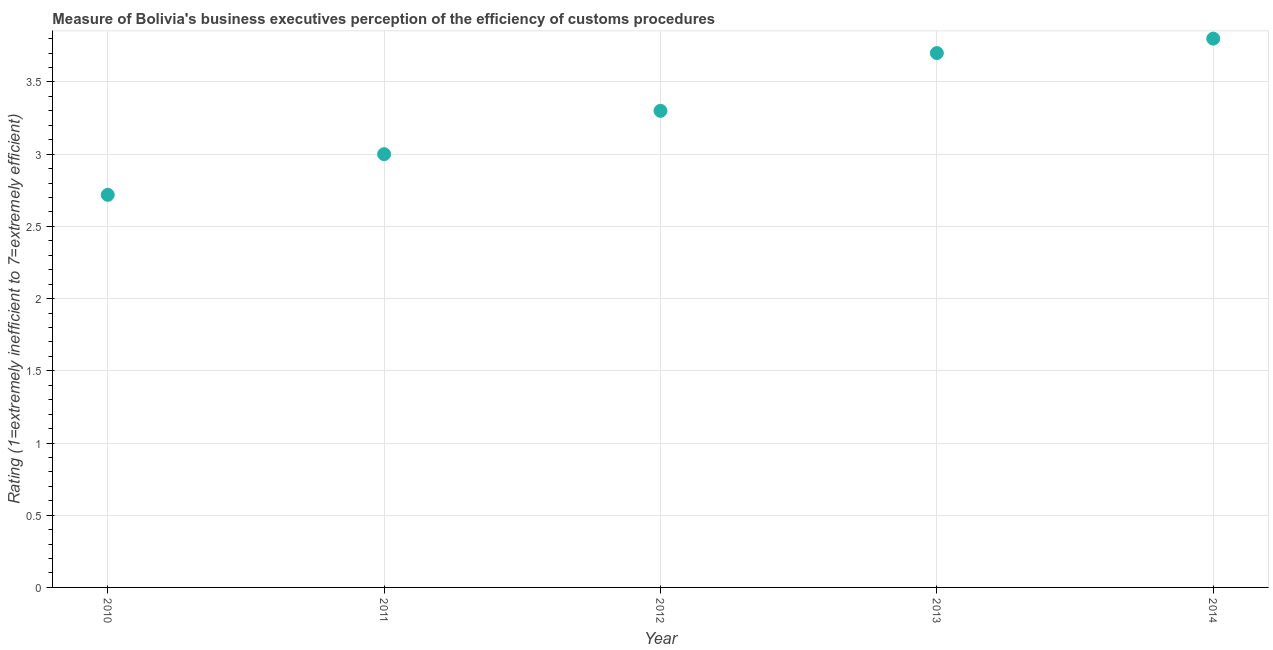Across all years, what is the minimum rating measuring burden of customs procedure?
Give a very brief answer. 2.72. What is the sum of the rating measuring burden of customs procedure?
Your answer should be very brief. 16.52. What is the difference between the rating measuring burden of customs procedure in 2010 and 2012?
Offer a very short reply. -0.58. What is the average rating measuring burden of customs procedure per year?
Make the answer very short. 3.3. What is the median rating measuring burden of customs procedure?
Provide a succinct answer. 3.3. What is the ratio of the rating measuring burden of customs procedure in 2013 to that in 2014?
Your response must be concise. 0.97. What is the difference between the highest and the second highest rating measuring burden of customs procedure?
Keep it short and to the point. 0.1. What is the difference between the highest and the lowest rating measuring burden of customs procedure?
Give a very brief answer. 1.08. In how many years, is the rating measuring burden of customs procedure greater than the average rating measuring burden of customs procedure taken over all years?
Offer a terse response. 2. Does the rating measuring burden of customs procedure monotonically increase over the years?
Your response must be concise. Yes. Does the graph contain any zero values?
Your answer should be compact. No. What is the title of the graph?
Provide a succinct answer. Measure of Bolivia's business executives perception of the efficiency of customs procedures. What is the label or title of the X-axis?
Keep it short and to the point. Year. What is the label or title of the Y-axis?
Offer a very short reply. Rating (1=extremely inefficient to 7=extremely efficient). What is the Rating (1=extremely inefficient to 7=extremely efficient) in 2010?
Keep it short and to the point. 2.72. What is the Rating (1=extremely inefficient to 7=extremely efficient) in 2012?
Keep it short and to the point. 3.3. What is the difference between the Rating (1=extremely inefficient to 7=extremely efficient) in 2010 and 2011?
Your response must be concise. -0.28. What is the difference between the Rating (1=extremely inefficient to 7=extremely efficient) in 2010 and 2012?
Give a very brief answer. -0.58. What is the difference between the Rating (1=extremely inefficient to 7=extremely efficient) in 2010 and 2013?
Give a very brief answer. -0.98. What is the difference between the Rating (1=extremely inefficient to 7=extremely efficient) in 2010 and 2014?
Ensure brevity in your answer.  -1.08. What is the difference between the Rating (1=extremely inefficient to 7=extremely efficient) in 2011 and 2012?
Make the answer very short. -0.3. What is the difference between the Rating (1=extremely inefficient to 7=extremely efficient) in 2011 and 2014?
Your answer should be compact. -0.8. What is the difference between the Rating (1=extremely inefficient to 7=extremely efficient) in 2013 and 2014?
Your answer should be compact. -0.1. What is the ratio of the Rating (1=extremely inefficient to 7=extremely efficient) in 2010 to that in 2011?
Make the answer very short. 0.91. What is the ratio of the Rating (1=extremely inefficient to 7=extremely efficient) in 2010 to that in 2012?
Ensure brevity in your answer.  0.82. What is the ratio of the Rating (1=extremely inefficient to 7=extremely efficient) in 2010 to that in 2013?
Keep it short and to the point. 0.73. What is the ratio of the Rating (1=extremely inefficient to 7=extremely efficient) in 2010 to that in 2014?
Your answer should be compact. 0.71. What is the ratio of the Rating (1=extremely inefficient to 7=extremely efficient) in 2011 to that in 2012?
Your answer should be very brief. 0.91. What is the ratio of the Rating (1=extremely inefficient to 7=extremely efficient) in 2011 to that in 2013?
Provide a short and direct response. 0.81. What is the ratio of the Rating (1=extremely inefficient to 7=extremely efficient) in 2011 to that in 2014?
Your response must be concise. 0.79. What is the ratio of the Rating (1=extremely inefficient to 7=extremely efficient) in 2012 to that in 2013?
Provide a succinct answer. 0.89. What is the ratio of the Rating (1=extremely inefficient to 7=extremely efficient) in 2012 to that in 2014?
Keep it short and to the point. 0.87. 